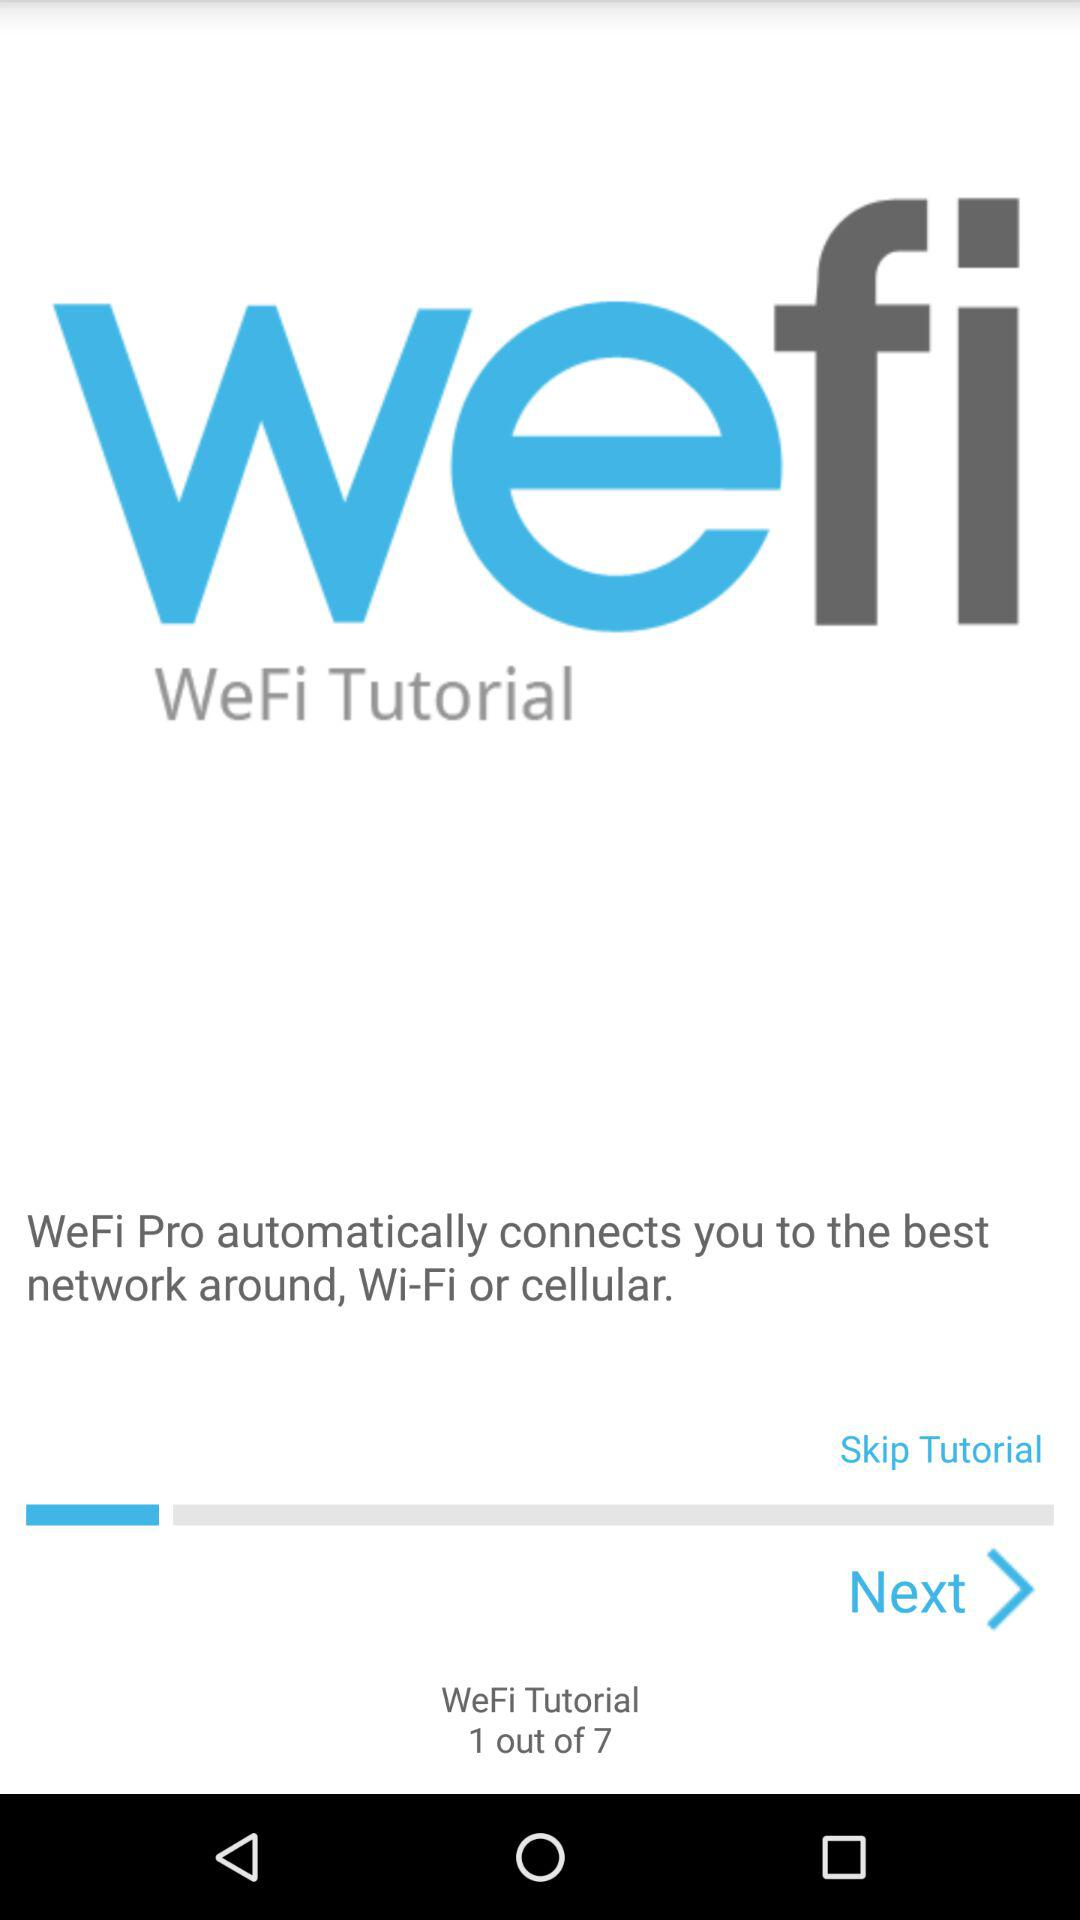On which page are we? You are on page number 1. 